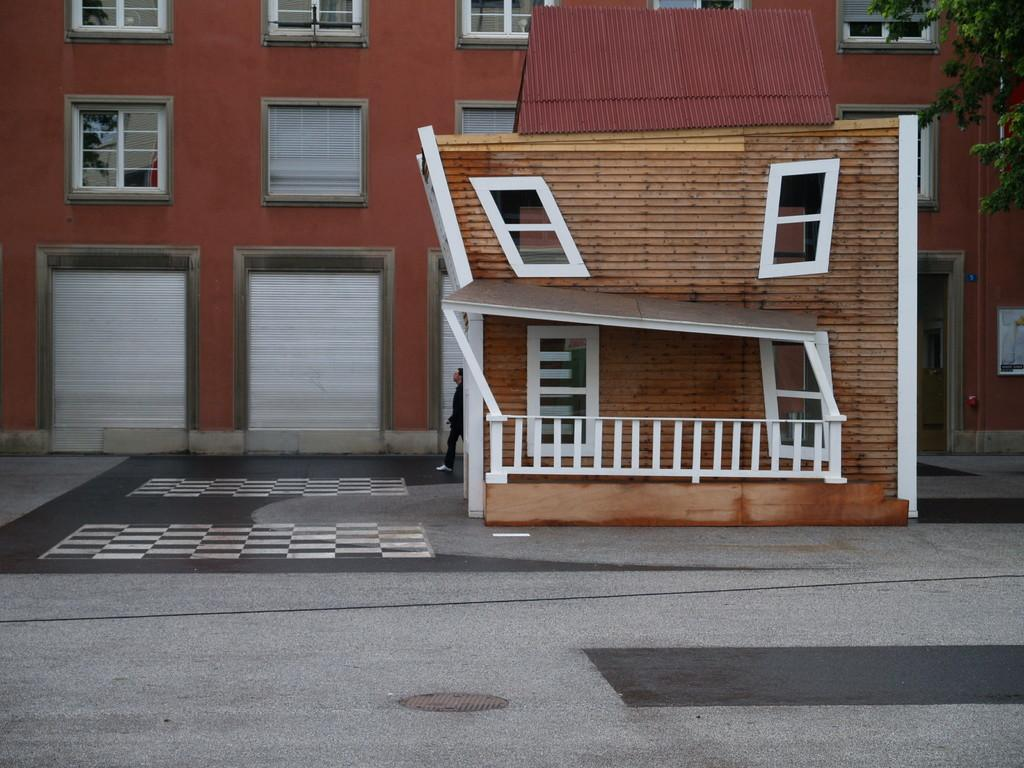What type of structure is visible in the image? There is a building in the image. What is the color of the building? The building is brown in color. What is located in front of the building? There is a road in front of the building. What type of vegetation can be seen on the right side of the image? There is a tree on the right side of the image. How many pets are visible in the room in the image? There is no room or pets present in the image; it features a building, a road, and a tree. 